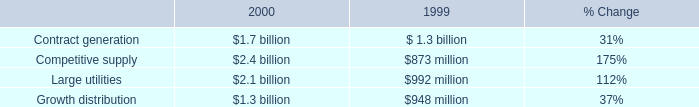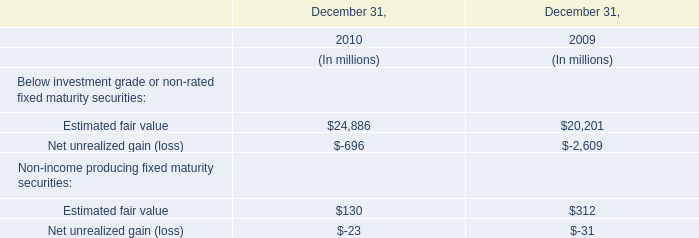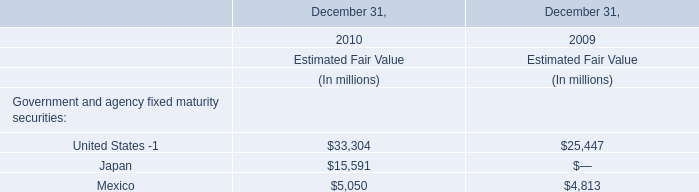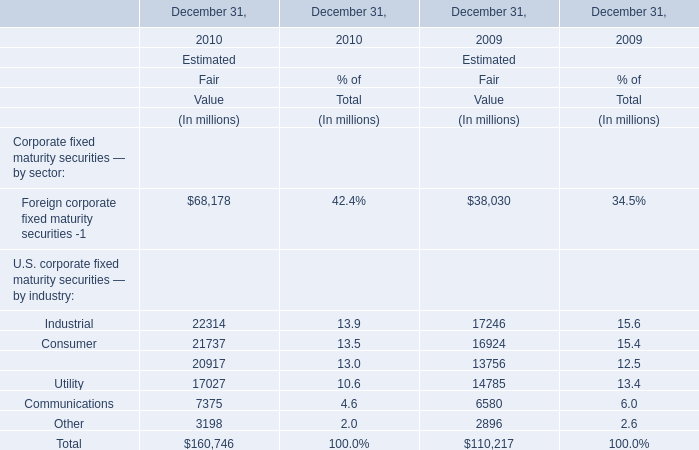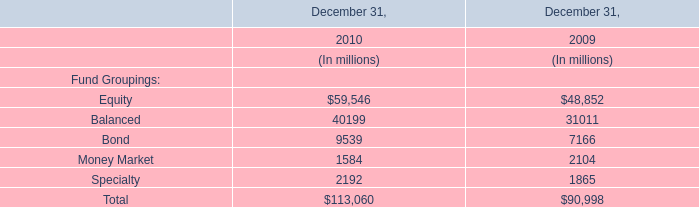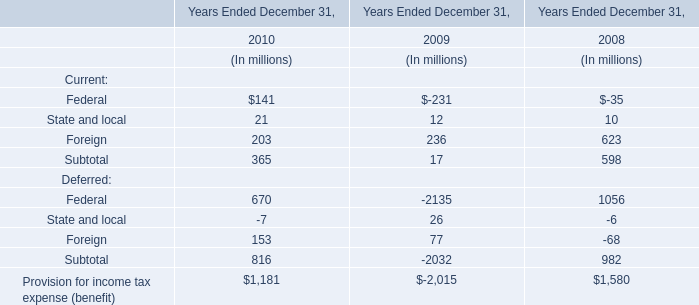What is the sum of Below investment grade or non-rated fixed maturity securities in 2010? (in million) 
Computations: (24886 - 696)
Answer: 24190.0. 